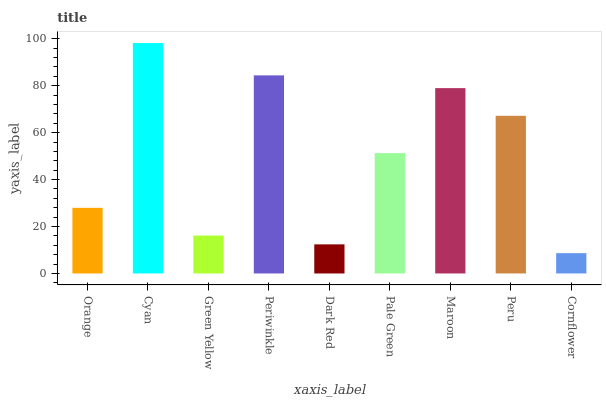Is Cornflower the minimum?
Answer yes or no. Yes. Is Cyan the maximum?
Answer yes or no. Yes. Is Green Yellow the minimum?
Answer yes or no. No. Is Green Yellow the maximum?
Answer yes or no. No. Is Cyan greater than Green Yellow?
Answer yes or no. Yes. Is Green Yellow less than Cyan?
Answer yes or no. Yes. Is Green Yellow greater than Cyan?
Answer yes or no. No. Is Cyan less than Green Yellow?
Answer yes or no. No. Is Pale Green the high median?
Answer yes or no. Yes. Is Pale Green the low median?
Answer yes or no. Yes. Is Peru the high median?
Answer yes or no. No. Is Peru the low median?
Answer yes or no. No. 